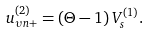Convert formula to latex. <formula><loc_0><loc_0><loc_500><loc_500>u _ { \upsilon n + } ^ { ( 2 ) } = \left ( \Theta - 1 \right ) V _ { s } ^ { ( 1 ) } .</formula> 